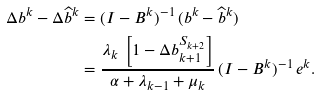<formula> <loc_0><loc_0><loc_500><loc_500>\Delta b ^ { k } - \Delta \widehat { b } ^ { k } & = ( I - B ^ { k } ) ^ { - 1 } \, ( b ^ { k } - \widehat { b } ^ { k } ) \\ & = \frac { \lambda _ { k } \, \left [ 1 - \Delta b ^ { S _ { k + 2 } } _ { k + 1 } \right ] } { \alpha + \lambda _ { k - 1 } + \mu _ { k } } \, ( I - B ^ { k } ) ^ { - 1 } \, e ^ { k } .</formula> 